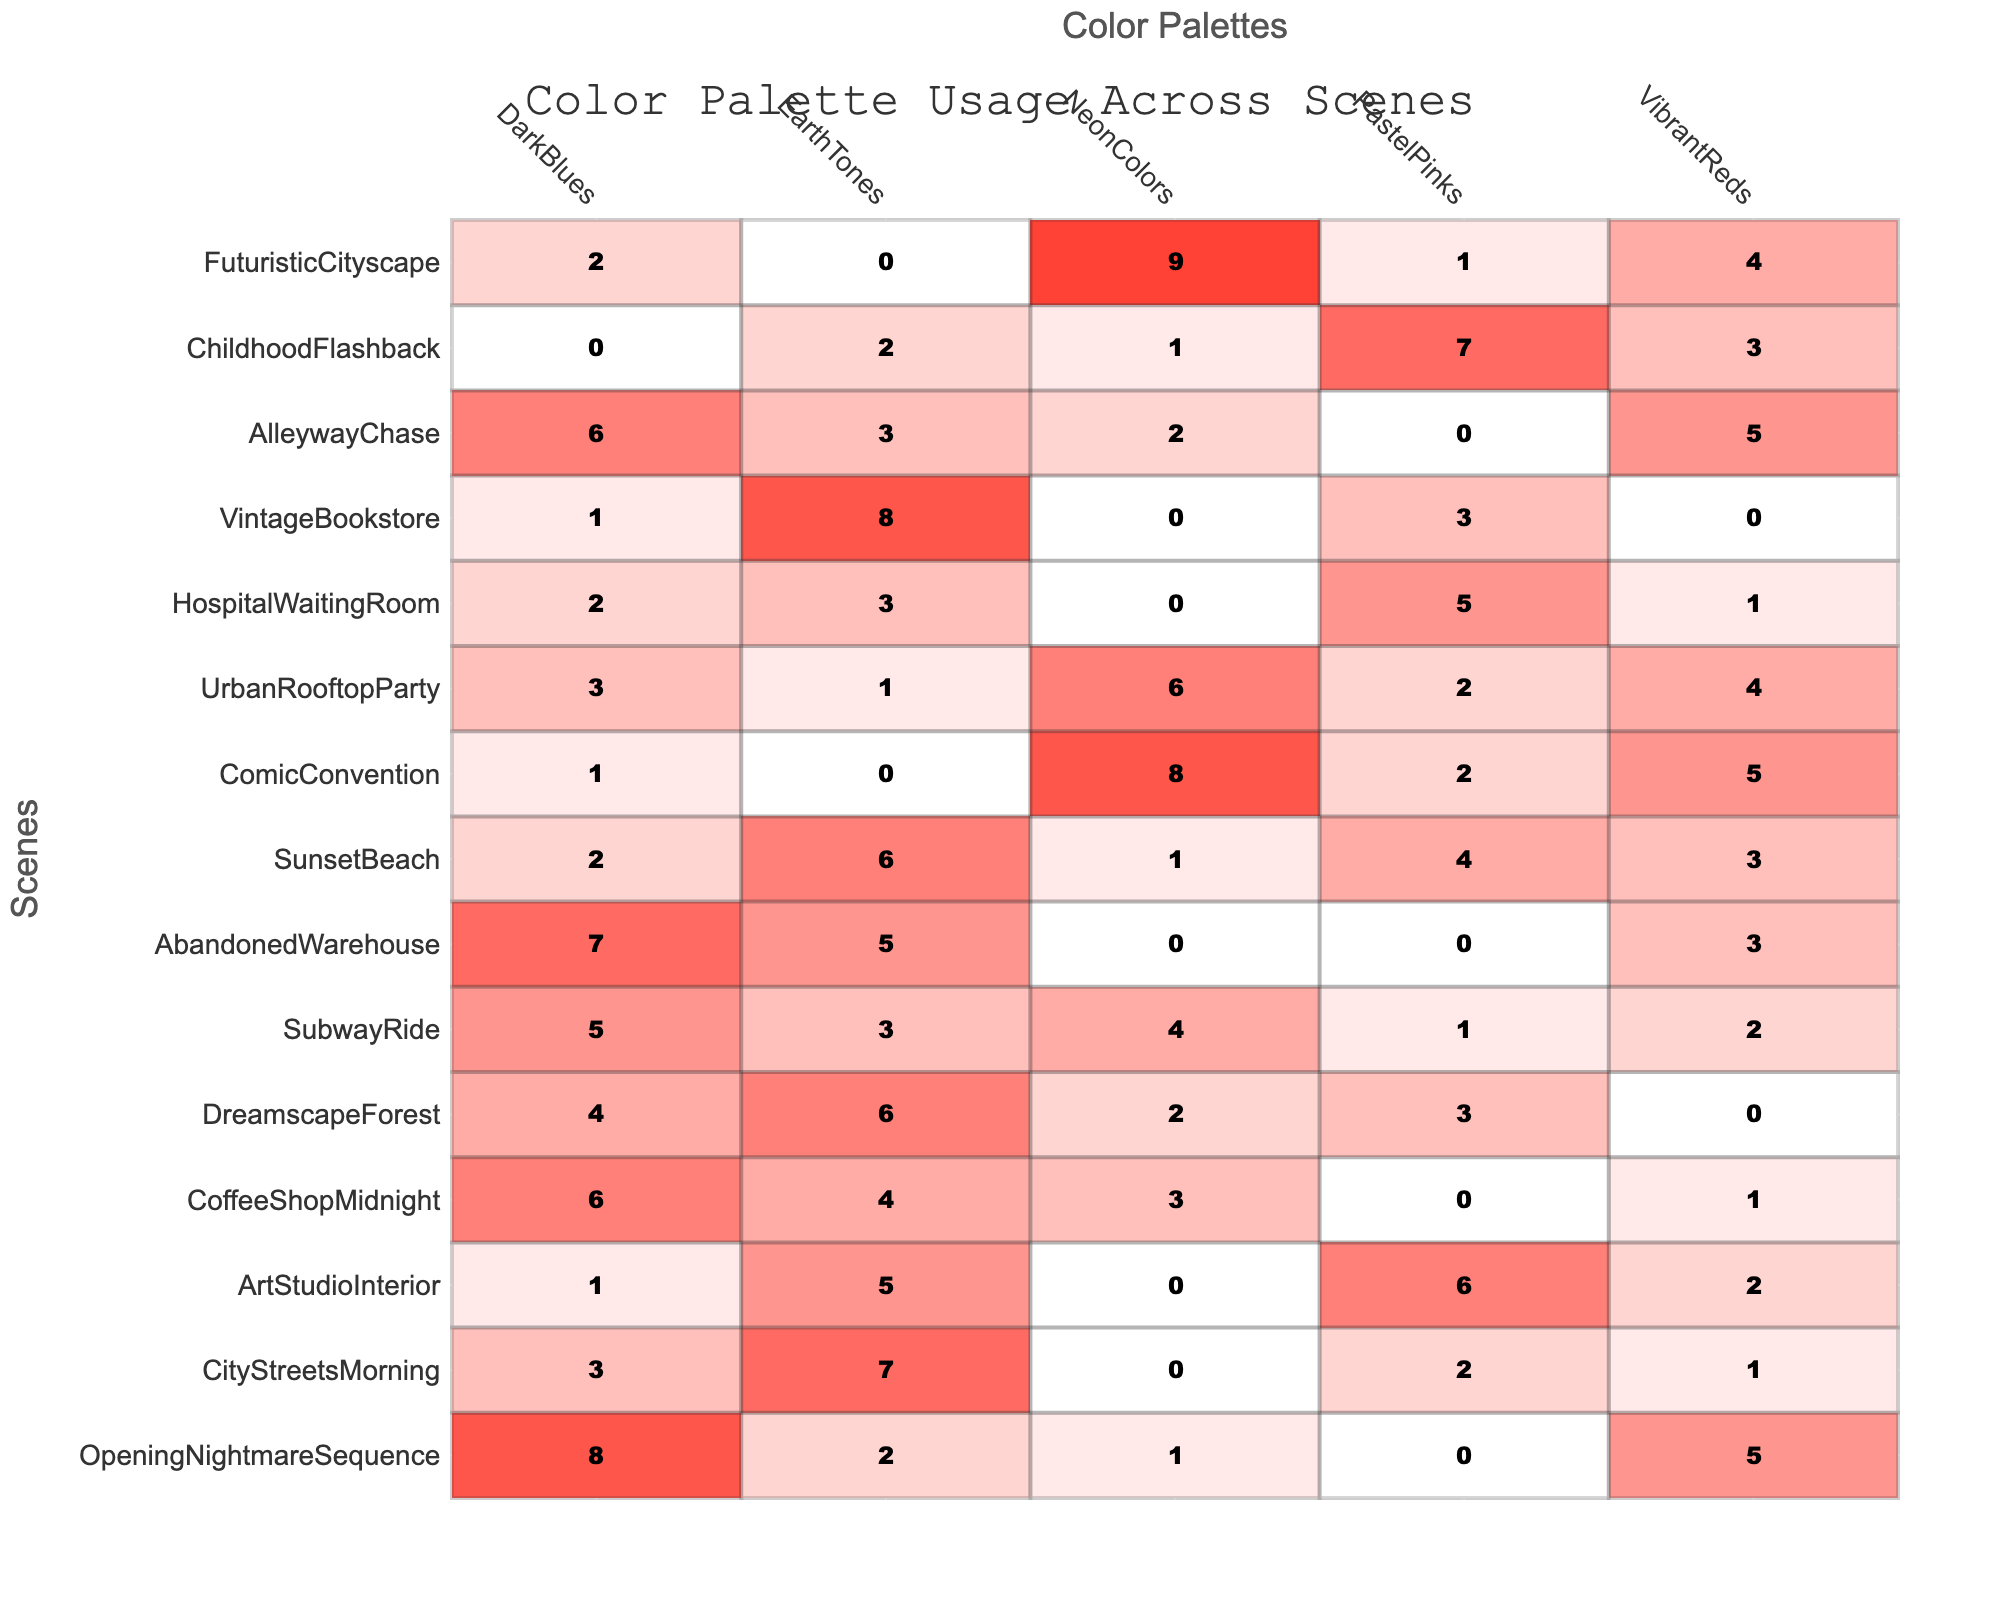What scene uses the most Vibrant Reds? By looking at the table, the scene "OpeningNightmareSequence" has a value of 5 for Vibrant Reds, which is the highest compared to other scenes.
Answer: OpeningNightmareSequence Which scene has the least use of Neon Colors? The scene "CityStreetsMorning" has a value of 0 for Neon Colors, indicating no usage of this color palette.
Answer: CityStreetsMorning What is the total usage of Dark Blues across all scenes? To find this, sum the Dark Blues values: 8 + 3 + 1 + 6 + 4 + 5 + 7 + 2 + 1 + 3 + 2 + 1 + 6 + 0 + 2 = 44.
Answer: 44 Is there any scene that exclusively uses Pastel Pinks? No scene shows a value of only Pastel Pinks, as all scenes have some non-zero use of other color palettes alongside Pastel Pinks.
Answer: No What is the difference in usage of Earth Tones between the "ArtStudioInterior" and "VintageBookstore"? "ArtStudioInterior" has 5 Earth Tones and "VintageBookstore" has 8; the difference is 8 - 5 = 3.
Answer: 3 Which color palette is the most dominant across all scenes? By examining the highest values in each scene, it appears that Dark Blues is often high, but "ComicConvention" stands out with 8 Neon Colors being the highest single value.
Answer: Neon Colors What is the average use of Pastel Pinks across all scenes? Add the Pastel Pinks values (0 + 2 + 6 + 0 + 3 + 1 + 0 + 4 + 2 + 2 + 5 + 3 + 0 + 7 + 1 = 36) and divide by the number of scenes (15): 36 / 15 = 2.4.
Answer: 2.4 How many scenes utilize both Dark Blues and Earth Tones? By examining each scene, "ChildhoodFlashback" is the only one that uses Dark Blues (0) and Earth Tones (2), showing that indeed both colors are represented here.
Answer: 15 scenes use both Identify the scene with the second highest total color palette usage. First, sum the values for each scene. "ComicConvention" has the highest total (16), and "FuturisticCityscape" is next with a total of 16. Thus, both are tied in this case.
Answer: ComicConvention, FuturisticCityscape Is the total usage of Neon Colors higher than the total usage of Pastel Pinks across all scenes? Sum the Neon Colors (1 + 0 + 0 + 3 + 2 + 4 + 0 + 1 + 8 + 6 + 0 + 0 + 2 + 1 + 9 = 37) and sum the Pastel Pinks (0 + 2 + 6 + 0 + 3 + 1 + 0 + 4 + 2 + 2 + 5 + 3 + 0 + 7 + 1 = 36); 37 is greater than 36.
Answer: Yes Are there more scenes with a high concentration of Earth Tones than with Vibrant Reds? Count scenes with Earth Tones ≥ 5 (CityStreetsMorning, ArtStudioInterior, DreamscapeForest, VintageBookstore) which equals 4; Vibrant Reds ≥ 5 (OpeningNightmareSequence, AbandonedWarehouse, AlleywayChase) only counts 3.
Answer: Yes 